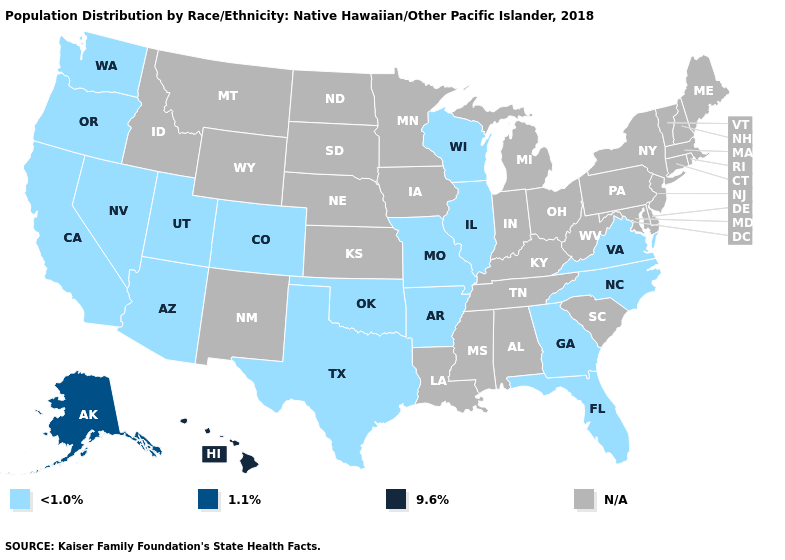Does Hawaii have the highest value in the USA?
Be succinct. Yes. Does the map have missing data?
Concise answer only. Yes. Does the map have missing data?
Give a very brief answer. Yes. What is the value of Missouri?
Give a very brief answer. <1.0%. Name the states that have a value in the range N/A?
Quick response, please. Alabama, Connecticut, Delaware, Idaho, Indiana, Iowa, Kansas, Kentucky, Louisiana, Maine, Maryland, Massachusetts, Michigan, Minnesota, Mississippi, Montana, Nebraska, New Hampshire, New Jersey, New Mexico, New York, North Dakota, Ohio, Pennsylvania, Rhode Island, South Carolina, South Dakota, Tennessee, Vermont, West Virginia, Wyoming. Name the states that have a value in the range 1.1%?
Give a very brief answer. Alaska. What is the value of Rhode Island?
Concise answer only. N/A. Which states have the highest value in the USA?
Give a very brief answer. Hawaii. What is the highest value in the USA?
Answer briefly. 9.6%. What is the value of Hawaii?
Quick response, please. 9.6%. Does Hawaii have the highest value in the USA?
Concise answer only. Yes. Name the states that have a value in the range N/A?
Write a very short answer. Alabama, Connecticut, Delaware, Idaho, Indiana, Iowa, Kansas, Kentucky, Louisiana, Maine, Maryland, Massachusetts, Michigan, Minnesota, Mississippi, Montana, Nebraska, New Hampshire, New Jersey, New Mexico, New York, North Dakota, Ohio, Pennsylvania, Rhode Island, South Carolina, South Dakota, Tennessee, Vermont, West Virginia, Wyoming. Name the states that have a value in the range N/A?
Be succinct. Alabama, Connecticut, Delaware, Idaho, Indiana, Iowa, Kansas, Kentucky, Louisiana, Maine, Maryland, Massachusetts, Michigan, Minnesota, Mississippi, Montana, Nebraska, New Hampshire, New Jersey, New Mexico, New York, North Dakota, Ohio, Pennsylvania, Rhode Island, South Carolina, South Dakota, Tennessee, Vermont, West Virginia, Wyoming. What is the highest value in the USA?
Short answer required. 9.6%. What is the value of North Dakota?
Give a very brief answer. N/A. 